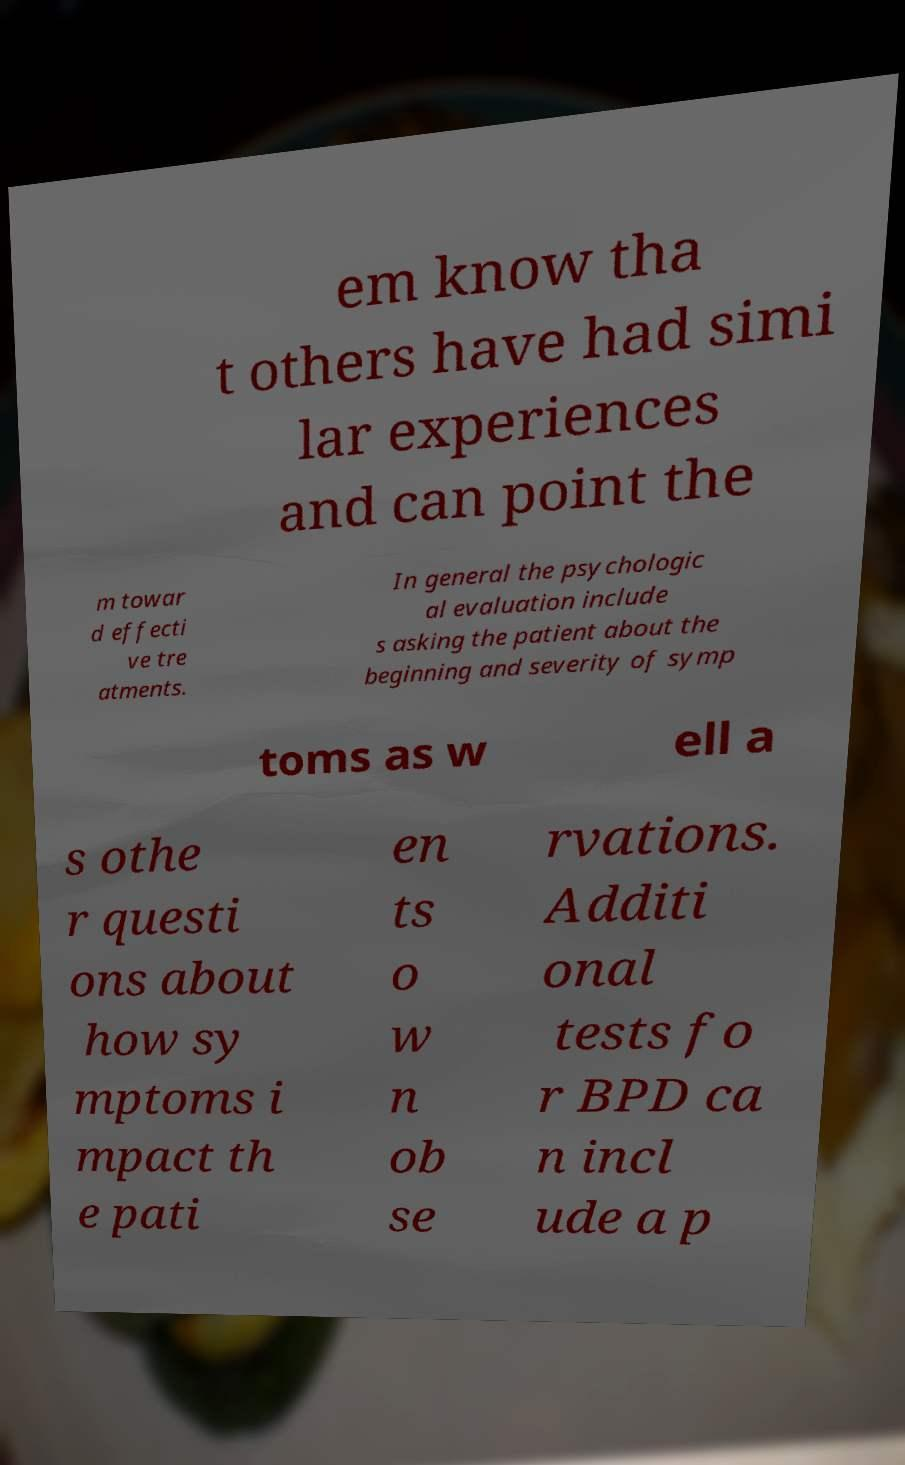Please read and relay the text visible in this image. What does it say? em know tha t others have had simi lar experiences and can point the m towar d effecti ve tre atments. In general the psychologic al evaluation include s asking the patient about the beginning and severity of symp toms as w ell a s othe r questi ons about how sy mptoms i mpact th e pati en ts o w n ob se rvations. Additi onal tests fo r BPD ca n incl ude a p 